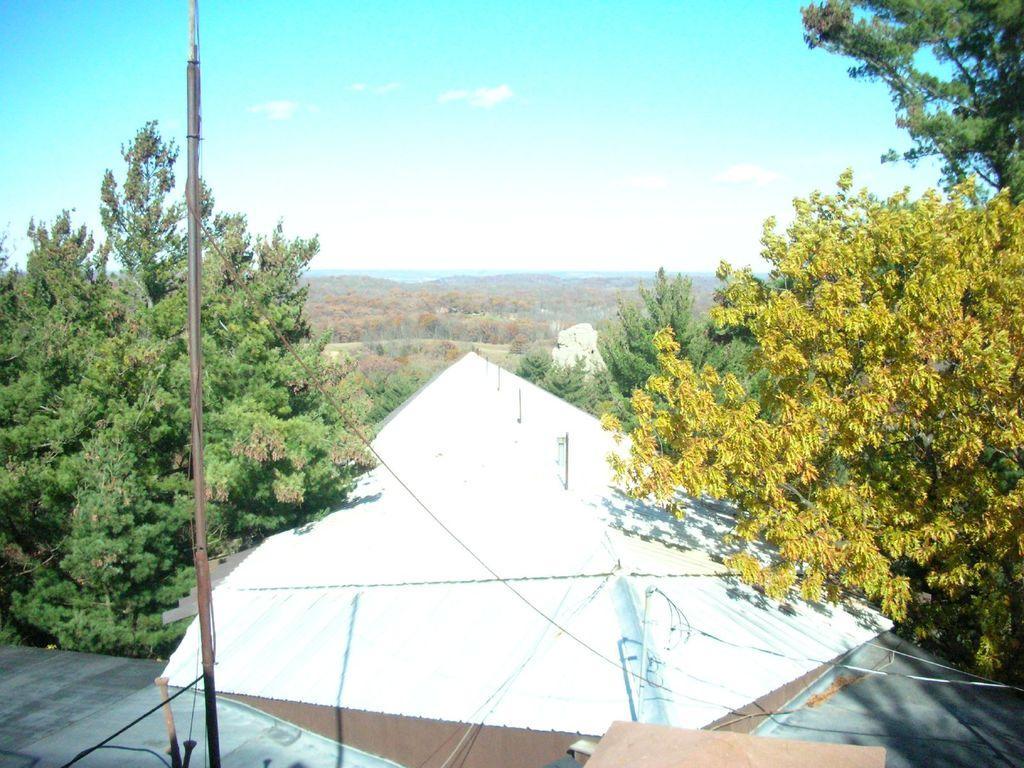Could you give a brief overview of what you see in this image? In this picture we can observe a white color tint. We can observe a pole on the left side. On the right side there is a yellow color tree. In the background there are some trees. We can observe a sky here. 